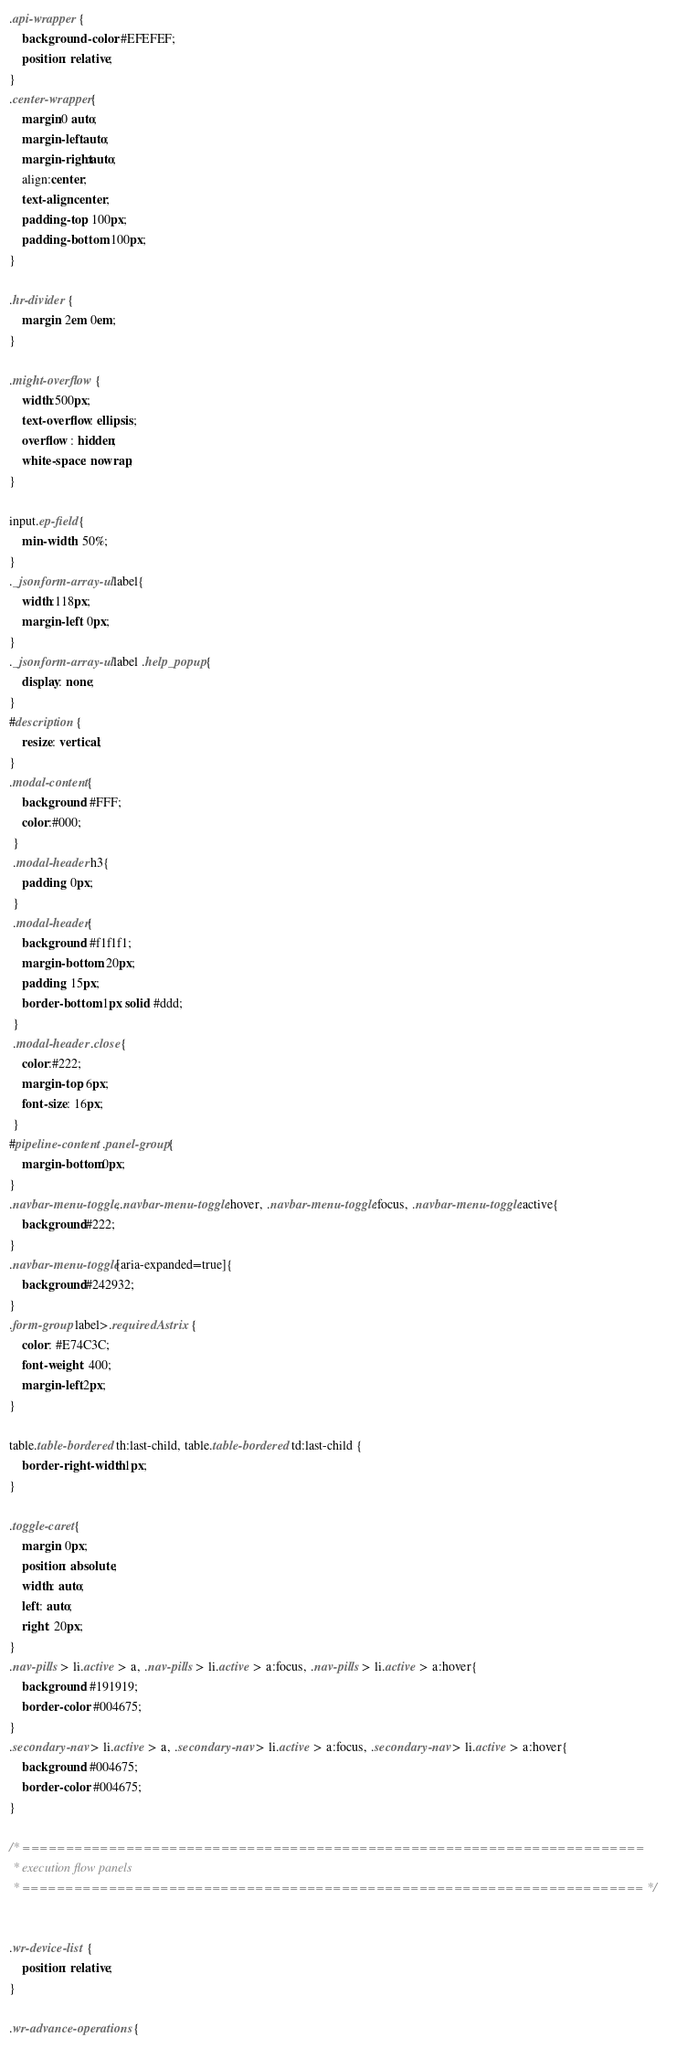<code> <loc_0><loc_0><loc_500><loc_500><_CSS_>.api-wrapper {
	background-color: #EFEFEF;
	position: relative;
}
.center-wrapper{
    margin:0 auto;
    margin-left:auto;
    margin-right:auto;
    align:center;
    text-align:center;
    padding-top: 100px;
    padding-bottom: 100px;
}

.hr-divider {
    margin: 2em 0em;
}

.might-overflow {
    width:500px;
    text-overflow: ellipsis;
    overflow : hidden;
    white-space: nowrap;
}

input.ep-field{
    min-width: 50%;
}
._jsonform-array-ul label{
    width:118px;
    margin-left: 0px;
}
._jsonform-array-ul label .help_popup{
    display: none;
}
#description {
    resize: vertical;
}
.modal-content{
    background: #FFF;
    color:#000;
 }
 .modal-header h3{
    padding: 0px;
 }
 .modal-header{
    background: #f1f1f1;
    margin-bottom: 20px;
    padding: 15px;
    border-bottom: 1px solid #ddd;
 }
 .modal-header .close{
    color:#222;
    margin-top: 6px;
    font-size: 16px;
 }
#pipeline-content .panel-group{
    margin-bottom:0px;
}
.navbar-menu-toggle,.navbar-menu-toggle:hover, .navbar-menu-toggle:focus, .navbar-menu-toggle:active{
    background:#222;
}
.navbar-menu-toggle[aria-expanded=true]{
    background:#242932;
}
.form-group label>.requiredAstrix {
    color: #E74C3C;
    font-weight: 400;
    margin-left:2px;
}

table.table-bordered th:last-child, table.table-bordered td:last-child {
    border-right-width: 1px;
}

.toggle-caret{
    margin: 0px;
    position: absolute;
    width: auto;
    left: auto;
    right: 20px;
}
.nav-pills > li.active > a, .nav-pills > li.active > a:focus, .nav-pills > li.active > a:hover{
    background: #191919;
    border-color: #004675;
}
.secondary-nav > li.active > a, .secondary-nav > li.active > a:focus, .secondary-nav > li.active > a:hover{
    background: #004675;
    border-color: #004675;
}

/* ========================================================================
 * execution flow panels
 * ======================================================================== */


.wr-device-list {
    position: relative;
}

.wr-advance-operations {</code> 